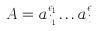Convert formula to latex. <formula><loc_0><loc_0><loc_500><loc_500>A = a _ { i _ { 1 } } ^ { \epsilon _ { 1 } } \dots a _ { i _ { L } } ^ { \epsilon _ { L } }</formula> 